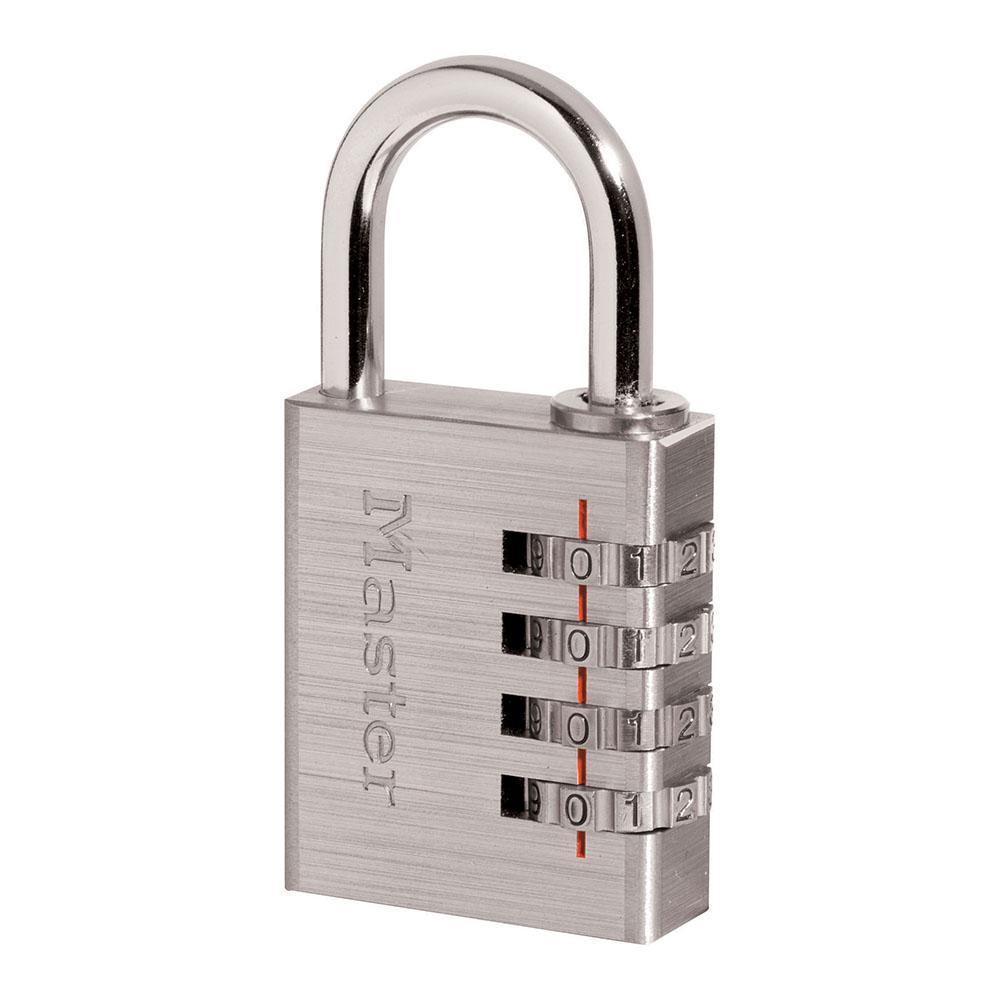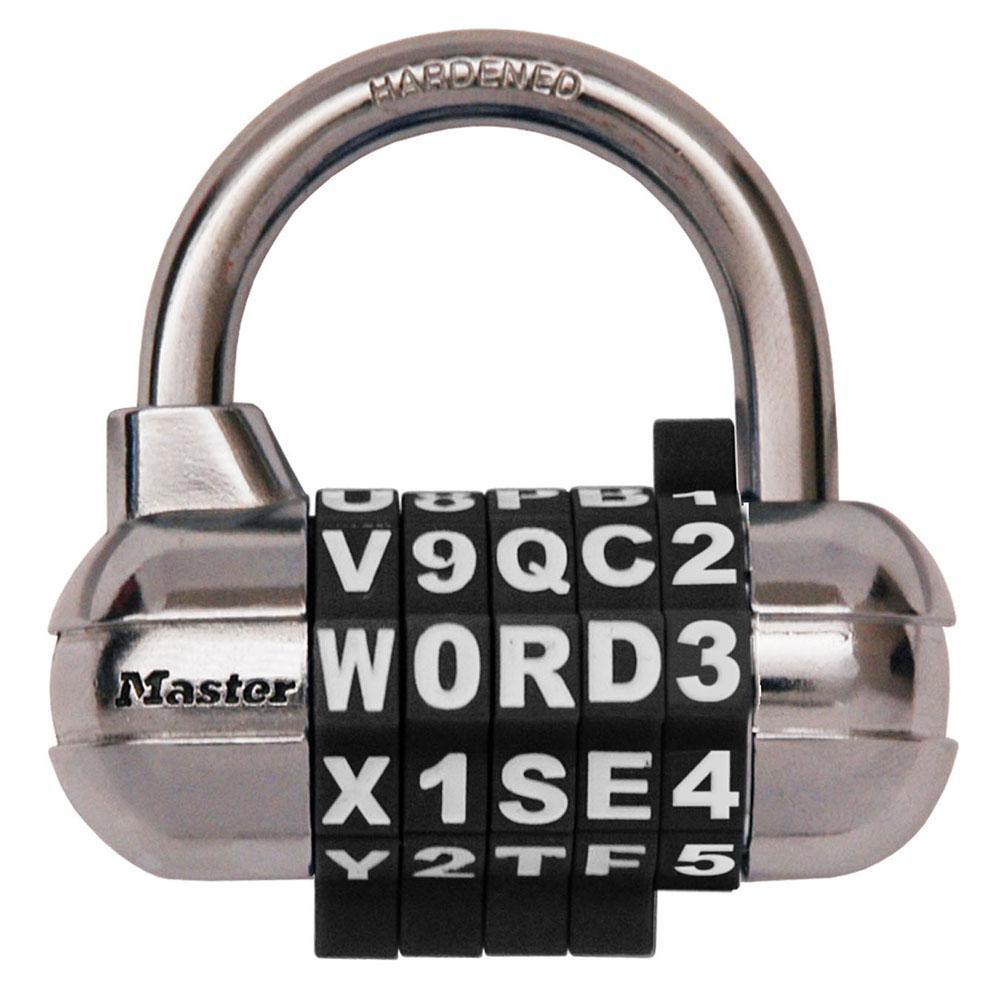The first image is the image on the left, the second image is the image on the right. Analyze the images presented: Is the assertion "Each lock is rectangular shaped, and one lock contains exactly three rows of numbers on wheels." valid? Answer yes or no. No. 